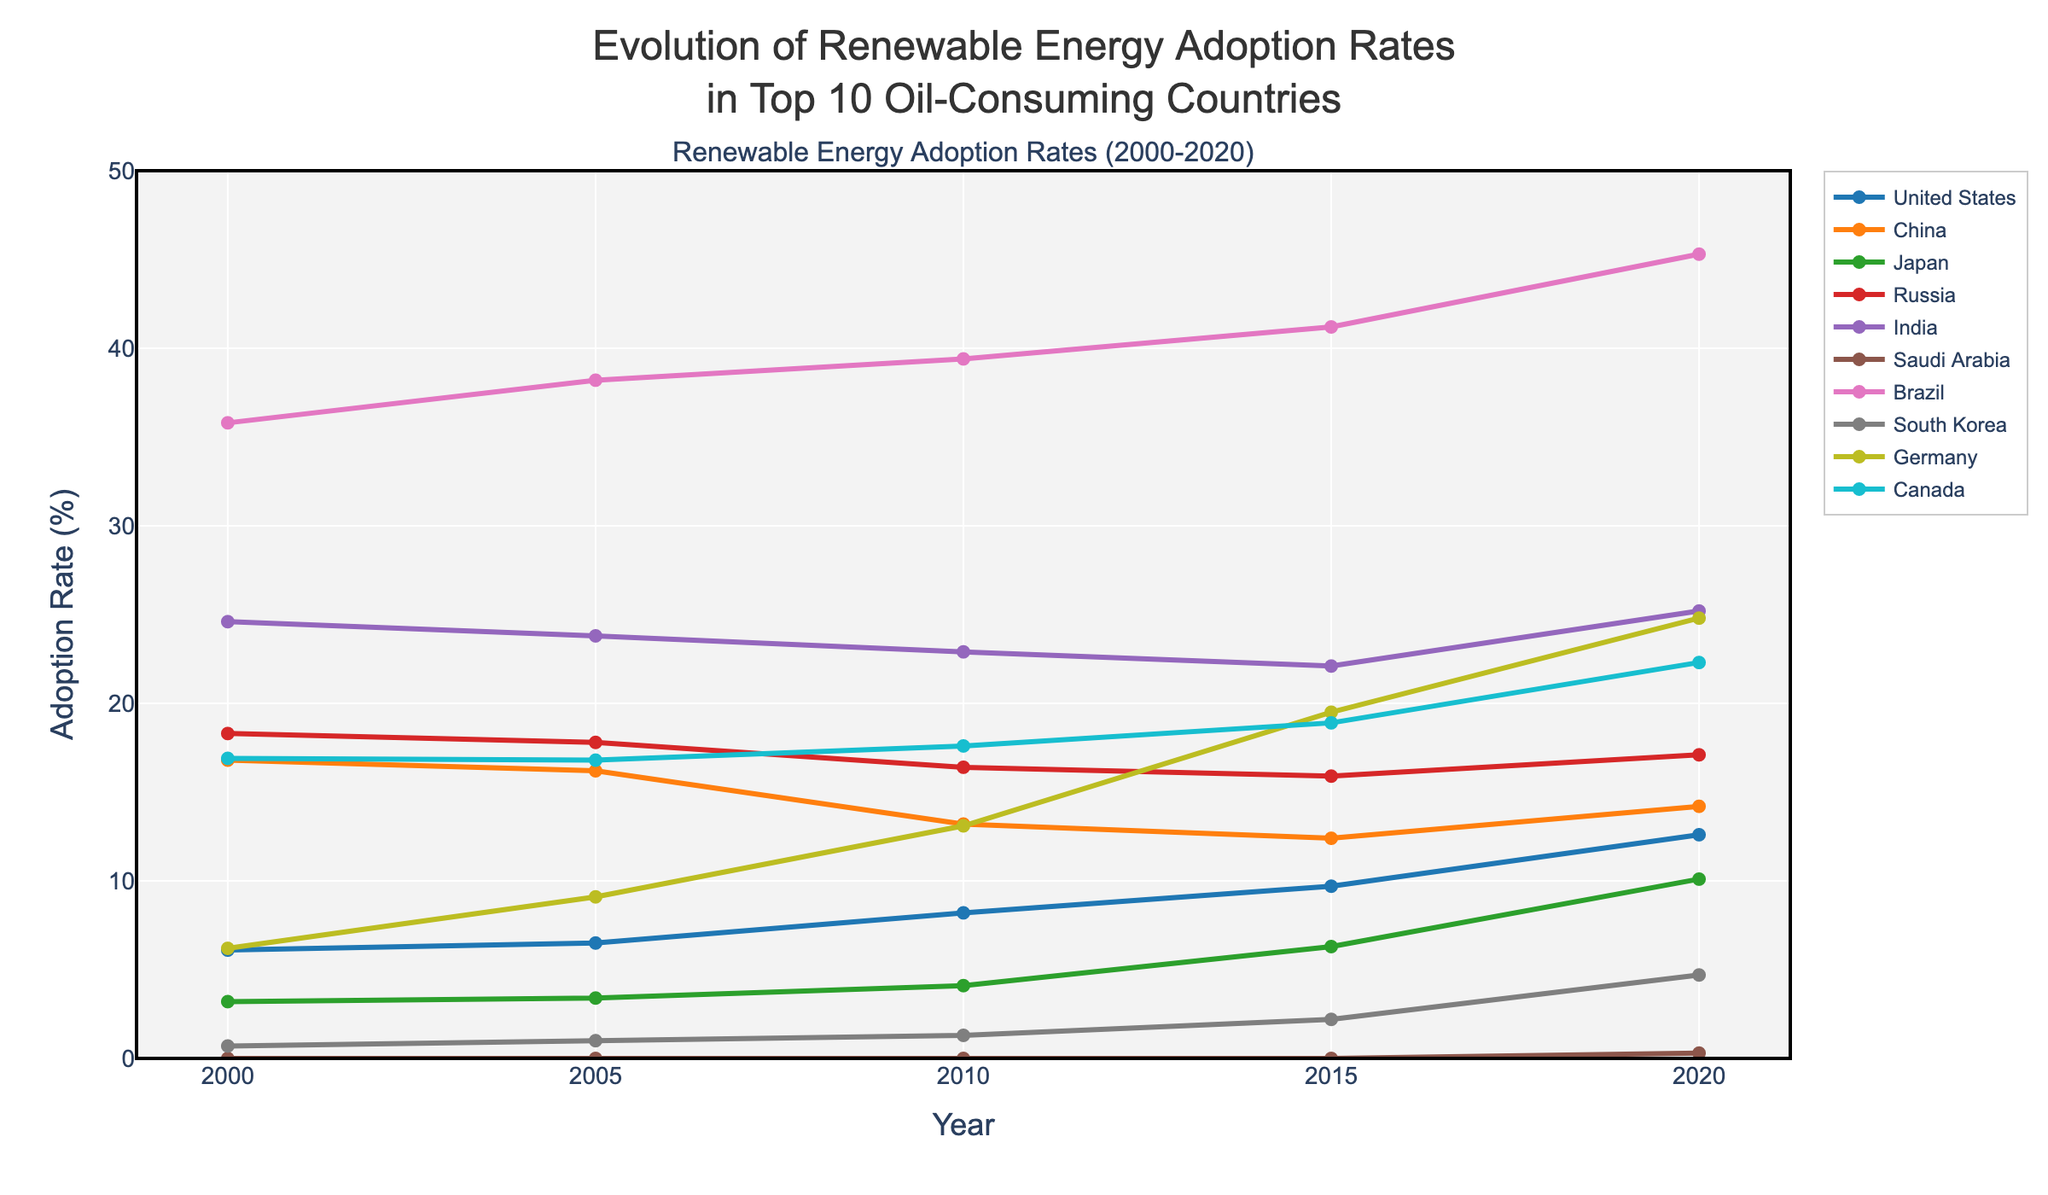Which country had the highest adoption rate of renewable energy in the year 2020? Look at the data points for the year 2020. The highest value is 45.3% for Brazil.
Answer: Brazil What is the difference in renewable energy adoption rates between 2010 and 2020 for South Korea? Find the adoption rates for South Korea in 2010 and 2020, which are 1.3% and 4.7% respectively. Subtract the 2010 rate from the 2020 rate: 4.7 - 1.3 = 3.4%.
Answer: 3.4% How many countries had an increase in renewable energy adoption rates from 2000 to 2020? Compare the 2000 and 2020 values for each country. Countries with increased rates are the United States, Japan, Saudi Arabia, Brazil, South Korea, Germany, and Canada.
Answer: 7 Which country showed the largest decrease in renewable energy adoption rates from 2000 to 2020? Look at the difference between adoption rates in 2000 and 2020 for each country. The largest decrease is for China, from 16.8% to 14.2%, a decrease of 2.6%.
Answer: China What is the average renewable energy adoption rate across all countries in the year 2015? Sum the rates for 2015 for all countries: 9.7 + 12.4 + 6.3 + 15.9 + 22.1 + 0.0 + 41.2 + 2.2 + 19.5 + 18.9 = 148.2, then divide by the number of countries: 148.2 / 10 = 14.82%.
Answer: 14.82% Between which consecutive years did Brazil show a visually noticeable rise in renewable energy adoption rates? Look at the line for Brazil. The visual rise is most noticeable between 2010 and 2015, going from 39.4% to 41.2%.
Answer: 2010-2015 Does any country show a fluctuation in renewable energy adoption rates over the two decades instead of a steady increase or decrease? Examine the lines for each country. China shows a fluctuation, starting at 16.8% in 2000, decreasing to 12.4% in 2015, and then rising to 14.2% in 2020.
Answer: China Which country had zero renewable energy adoption until 2020? Look at the data points. Saudi Arabia had zero adoption rates in 2000, 2005, 2010, and 2015, and only in 2020 did it have an adoption rate of 0.3%.
Answer: Saudi Arabia 